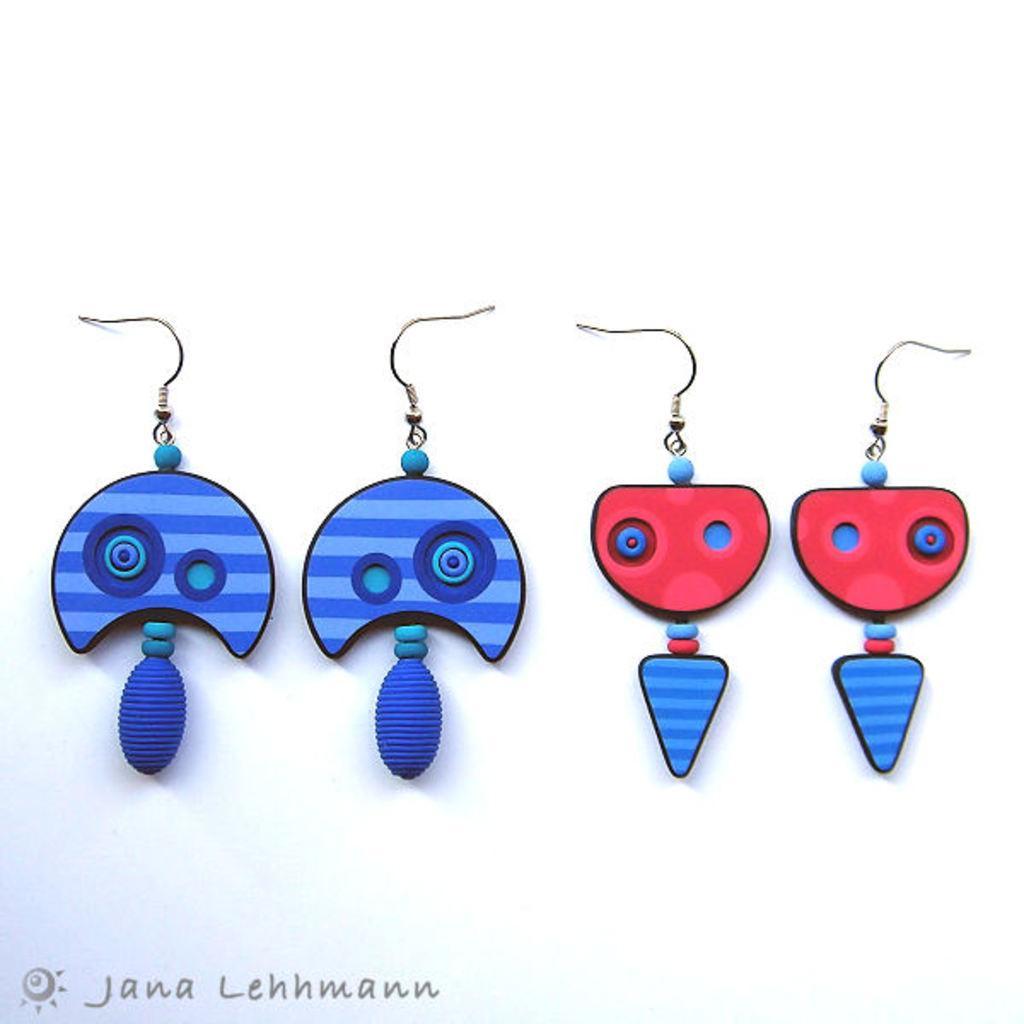Could you give a brief overview of what you see in this image? On the left side there are 2 earrings in blue color, on the right side there are 2 earrings in dark red color. 